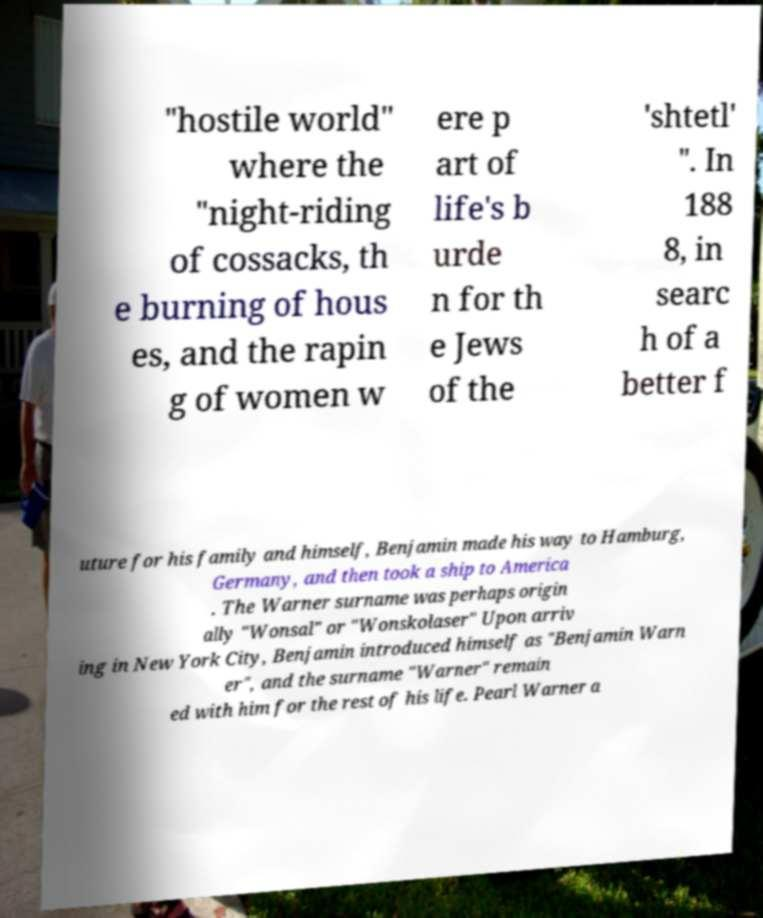Can you read and provide the text displayed in the image?This photo seems to have some interesting text. Can you extract and type it out for me? "hostile world" where the "night-riding of cossacks, th e burning of hous es, and the rapin g of women w ere p art of life's b urde n for th e Jews of the 'shtetl' ". In 188 8, in searc h of a better f uture for his family and himself, Benjamin made his way to Hamburg, Germany, and then took a ship to America . The Warner surname was perhaps origin ally "Wonsal" or "Wonskolaser" Upon arriv ing in New York City, Benjamin introduced himself as "Benjamin Warn er", and the surname "Warner" remain ed with him for the rest of his life. Pearl Warner a 